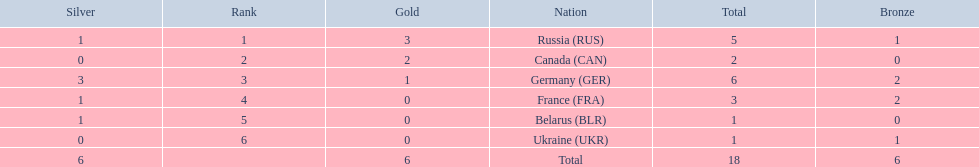What are all the countries in the 1994 winter olympics biathlon? Russia (RUS), Canada (CAN), Germany (GER), France (FRA), Belarus (BLR), Ukraine (UKR). Which of these received at least one gold medal? Russia (RUS), Canada (CAN), Germany (GER). Which of these received no silver or bronze medals? Canada (CAN). 